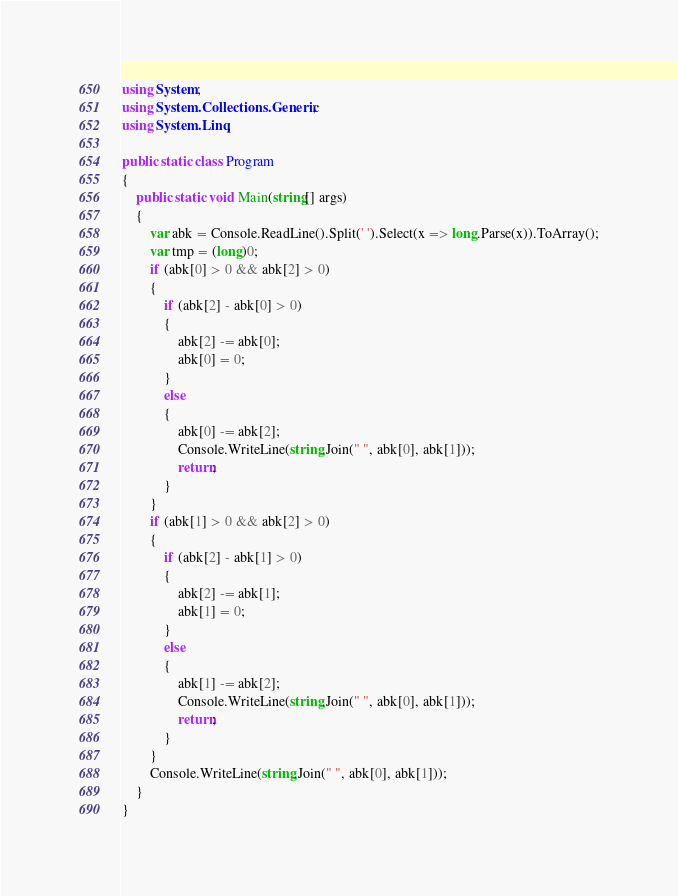<code> <loc_0><loc_0><loc_500><loc_500><_C#_>using System;
using System.Collections.Generic;
using System.Linq;

public static class Program
{
    public static void Main(string[] args)
    {
        var abk = Console.ReadLine().Split(' ').Select(x => long.Parse(x)).ToArray();
        var tmp = (long)0;
        if (abk[0] > 0 && abk[2] > 0)
        {
            if (abk[2] - abk[0] > 0)
            {
                abk[2] -= abk[0];
                abk[0] = 0;
            }
            else
            {
                abk[0] -= abk[2];
                Console.WriteLine(string.Join(" ", abk[0], abk[1]));
                return;
            }
        }
        if (abk[1] > 0 && abk[2] > 0)
        {
            if (abk[2] - abk[1] > 0)
            {
                abk[2] -= abk[1];
                abk[1] = 0;
            }
            else
            {
                abk[1] -= abk[2];
                Console.WriteLine(string.Join(" ", abk[0], abk[1]));
                return;
            }
        }
        Console.WriteLine(string.Join(" ", abk[0], abk[1]));
    }
}</code> 